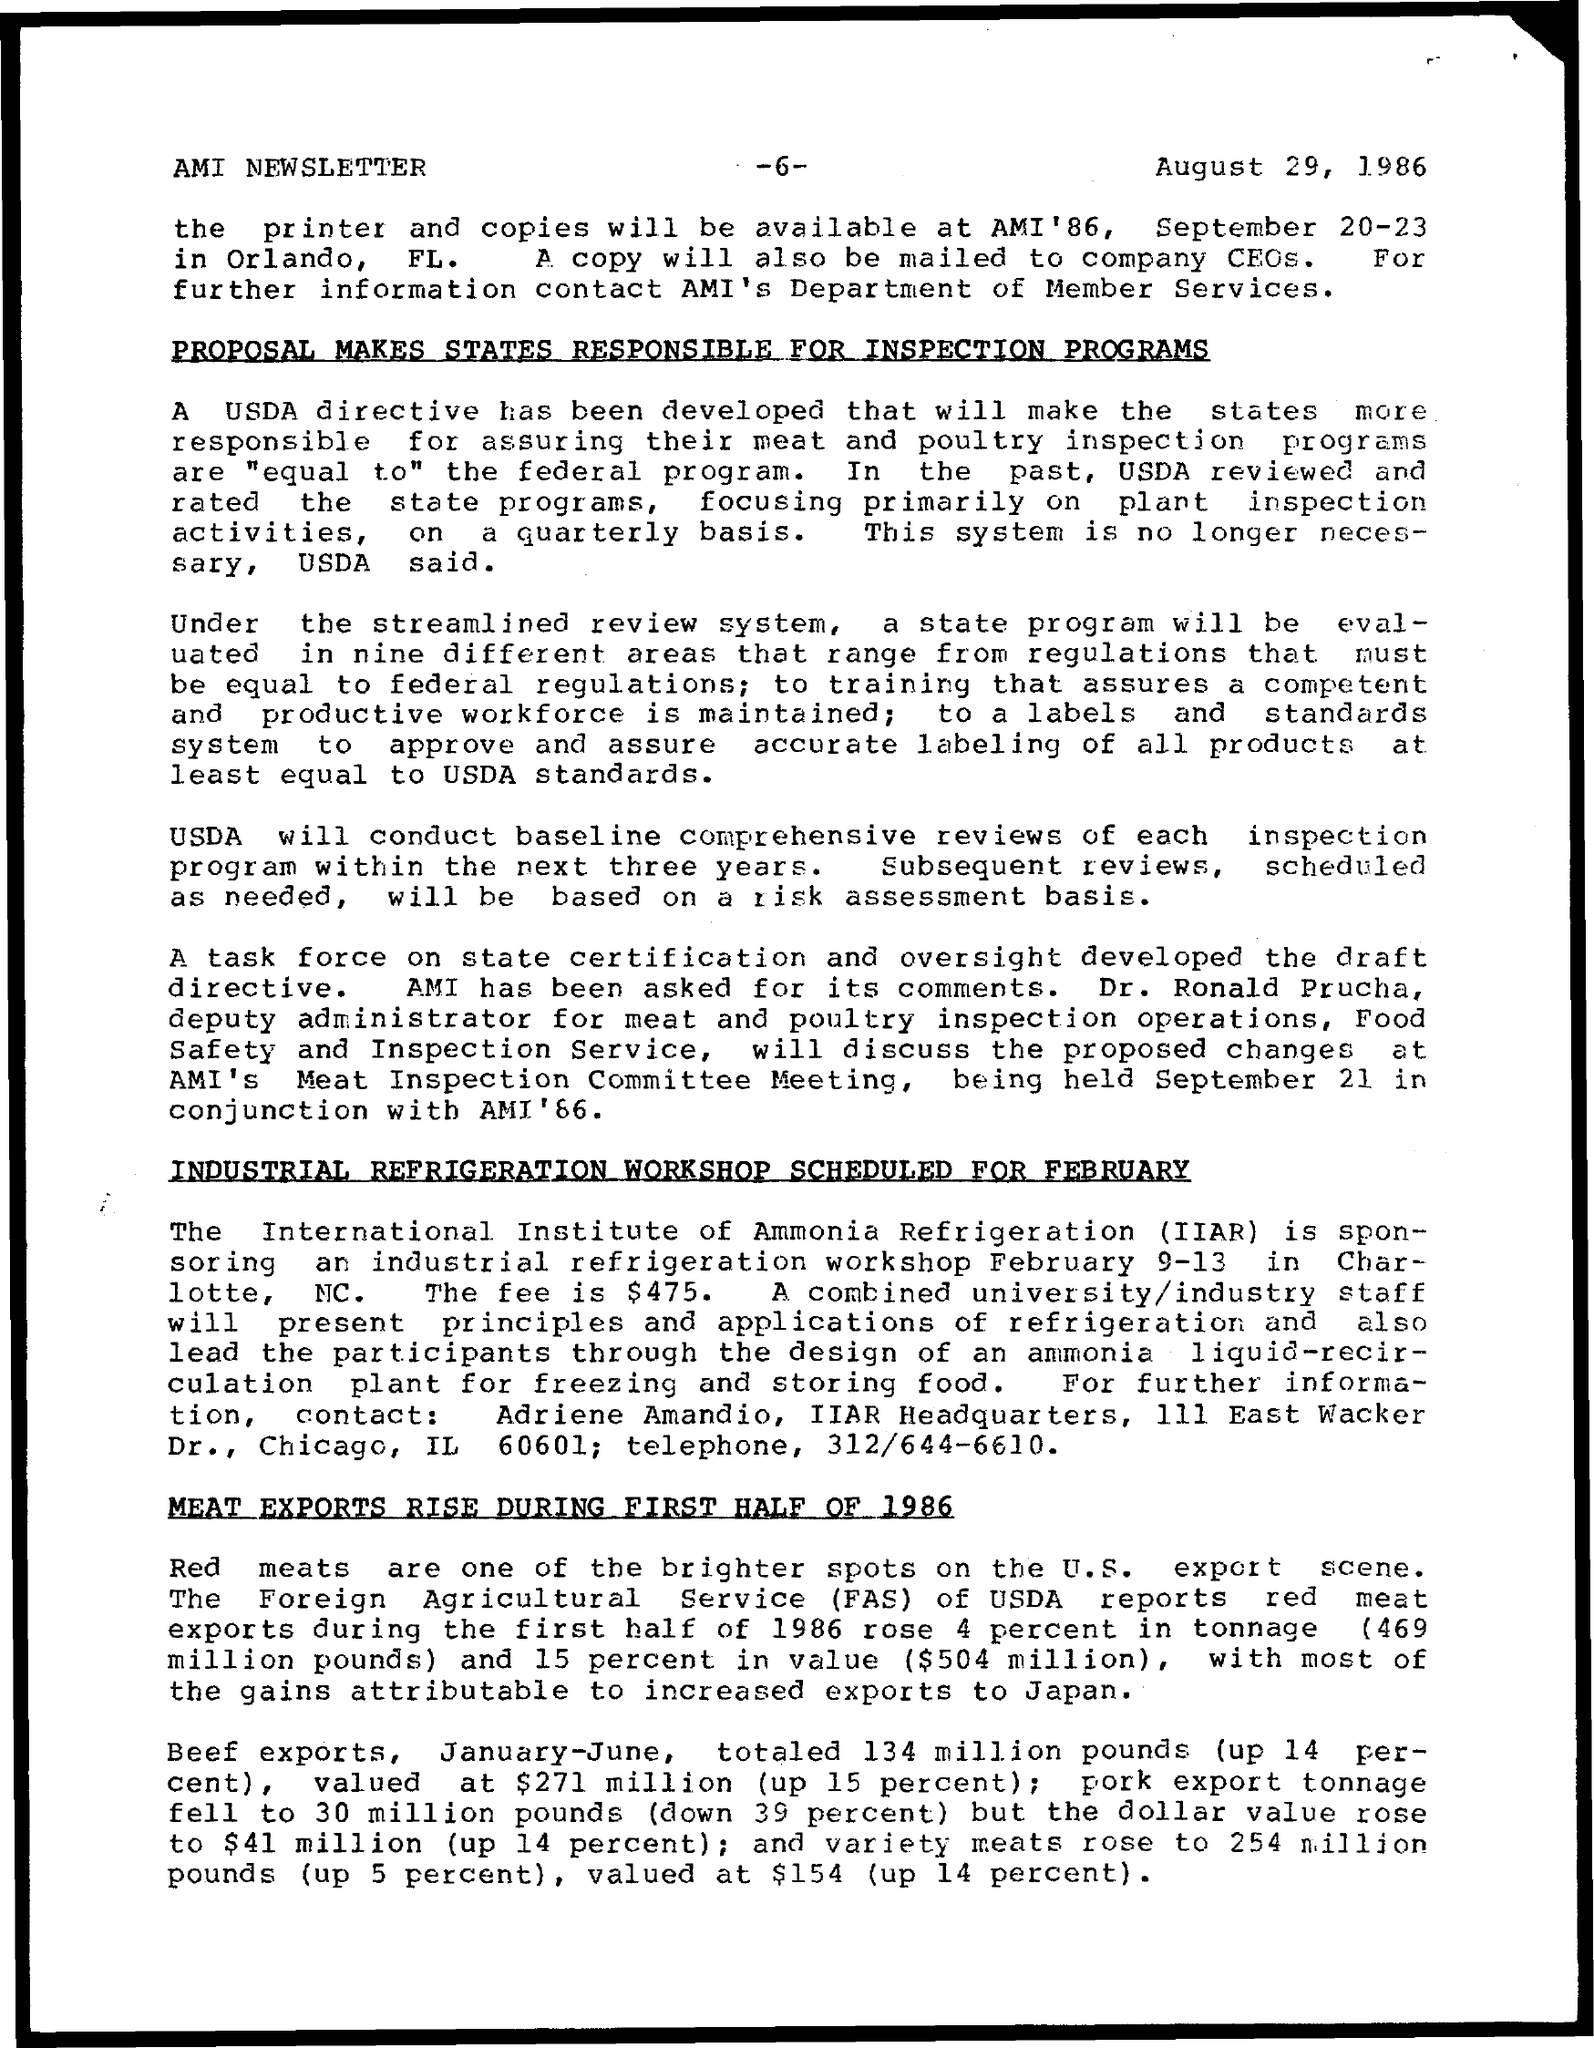Which month the Industrial refrigeration workshop scheduled?
Give a very brief answer. FEBRUARY. 